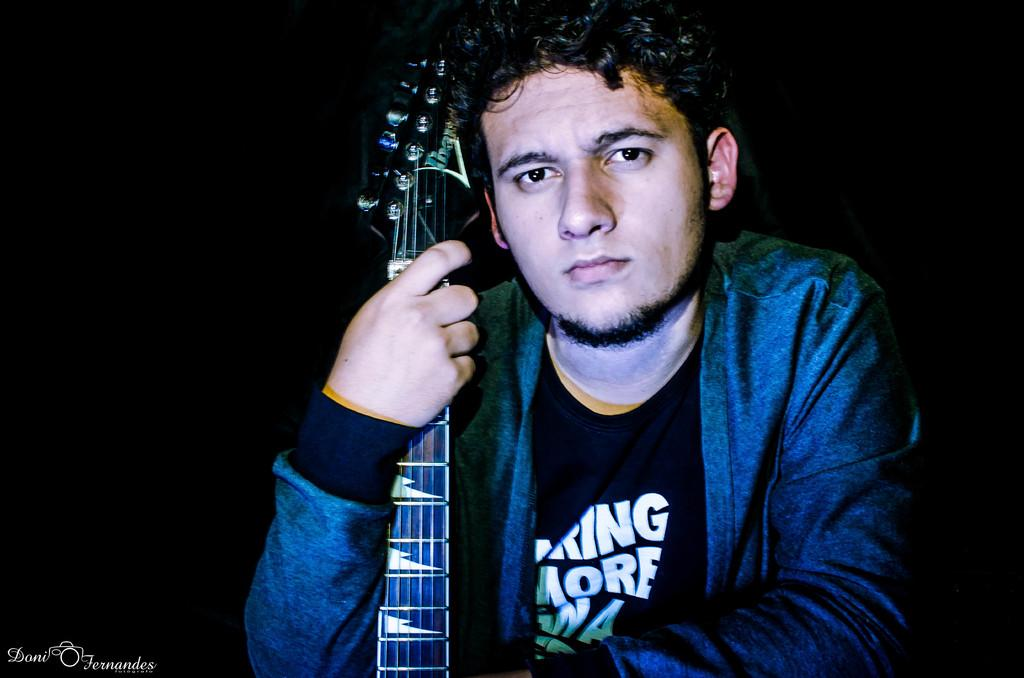What is the main subject of the image? There is a person in the image. What is the person holding in his hand? The person is holding a guitar in his hand. Can you describe the background of the image? The background of the image is dark. Is there a mailbox visible in the image? No, there is no mailbox present in the image. Can you see a kitty playing with steam in the image? No, there is no kitty or steam present in the image. 